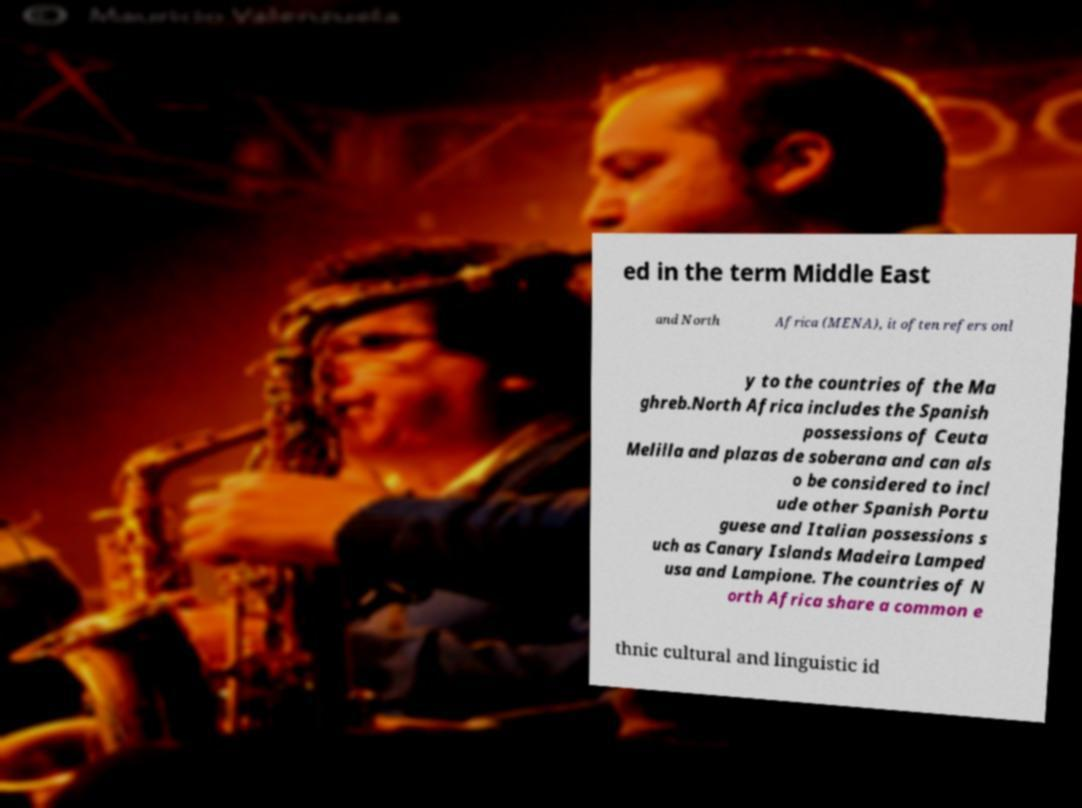Please identify and transcribe the text found in this image. ed in the term Middle East and North Africa (MENA), it often refers onl y to the countries of the Ma ghreb.North Africa includes the Spanish possessions of Ceuta Melilla and plazas de soberana and can als o be considered to incl ude other Spanish Portu guese and Italian possessions s uch as Canary Islands Madeira Lamped usa and Lampione. The countries of N orth Africa share a common e thnic cultural and linguistic id 